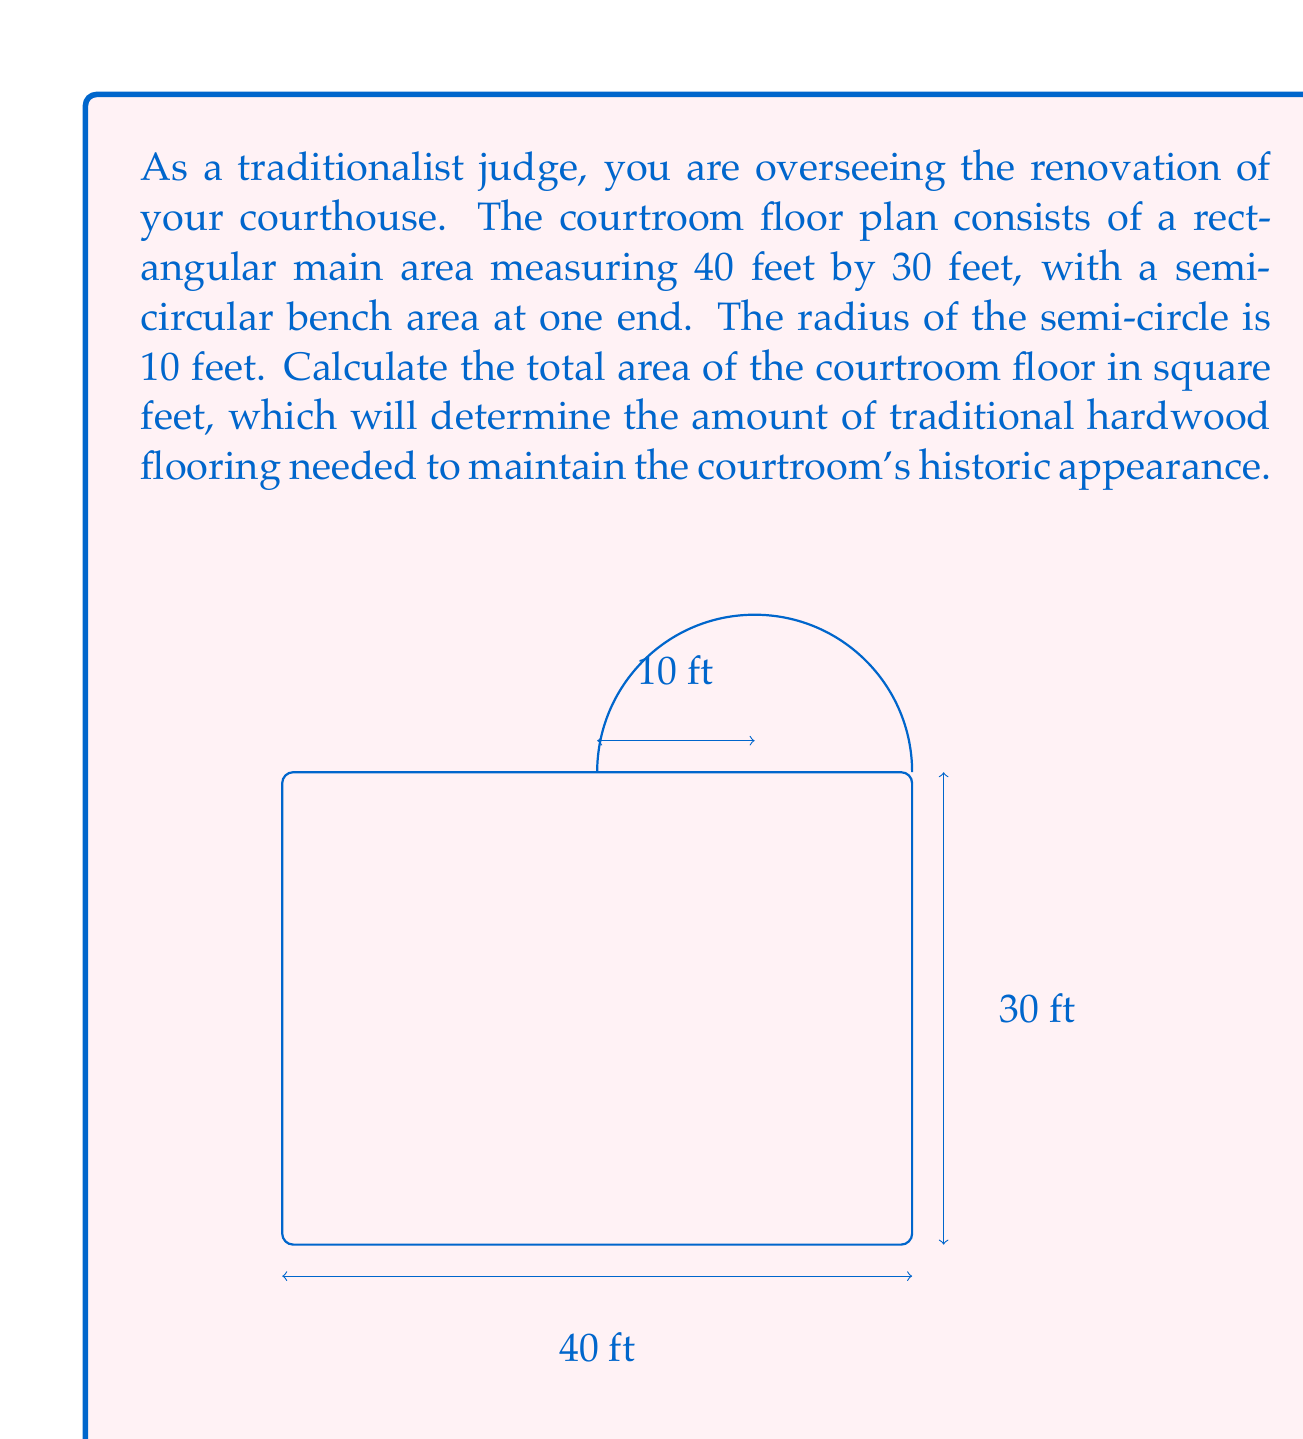Can you answer this question? To solve this problem, we need to calculate the areas of the rectangular main area and the semi-circular bench area separately, then add them together.

1. Area of the rectangular main area:
   $$ A_{rectangle} = length \times width = 40 \text{ ft} \times 30 \text{ ft} = 1200 \text{ sq ft} $$

2. Area of the semi-circular bench area:
   The area of a semi-circle is given by the formula: $A = \frac{1}{2} \pi r^2$
   $$ A_{semi-circle} = \frac{1}{2} \pi (10 \text{ ft})^2 = 50\pi \text{ sq ft} $$

3. Total area of the courtroom:
   $$ A_{total} = A_{rectangle} + A_{semi-circle} = 1200 \text{ sq ft} + 50\pi \text{ sq ft} $$

4. Simplify the expression:
   $$ A_{total} = 1200 + 50\pi \text{ sq ft} $$

5. Calculate the approximate value (rounded to the nearest square foot):
   $$ A_{total} \approx 1200 + 50(3.14159) \approx 1357 \text{ sq ft} $$

Therefore, the total area of the courtroom floor is $1200 + 50\pi$ square feet, or approximately 1357 square feet.
Answer: $1200 + 50\pi \text{ sq ft}$ (exact) or $1357 \text{ sq ft}$ (rounded to the nearest square foot) 